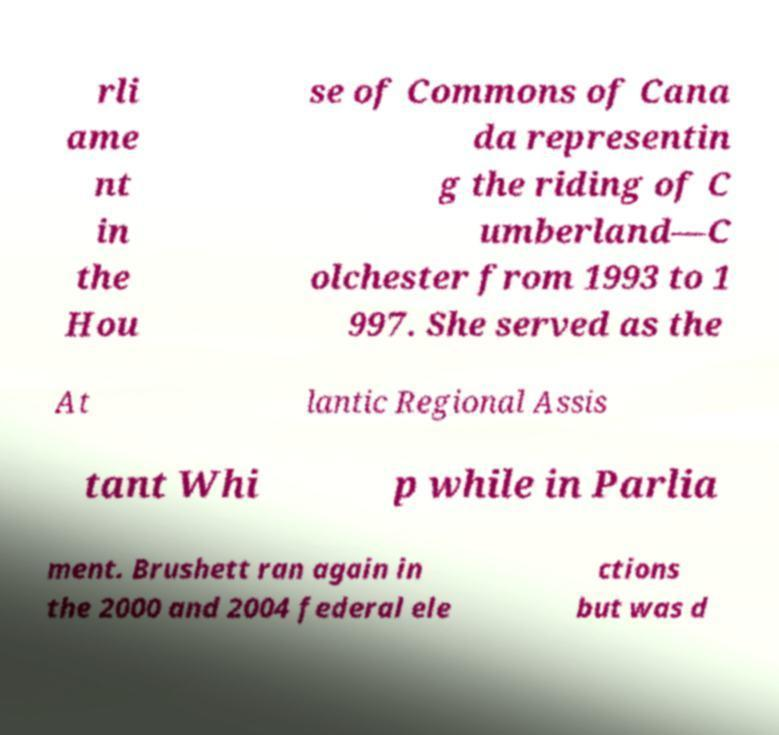Can you read and provide the text displayed in the image?This photo seems to have some interesting text. Can you extract and type it out for me? rli ame nt in the Hou se of Commons of Cana da representin g the riding of C umberland—C olchester from 1993 to 1 997. She served as the At lantic Regional Assis tant Whi p while in Parlia ment. Brushett ran again in the 2000 and 2004 federal ele ctions but was d 